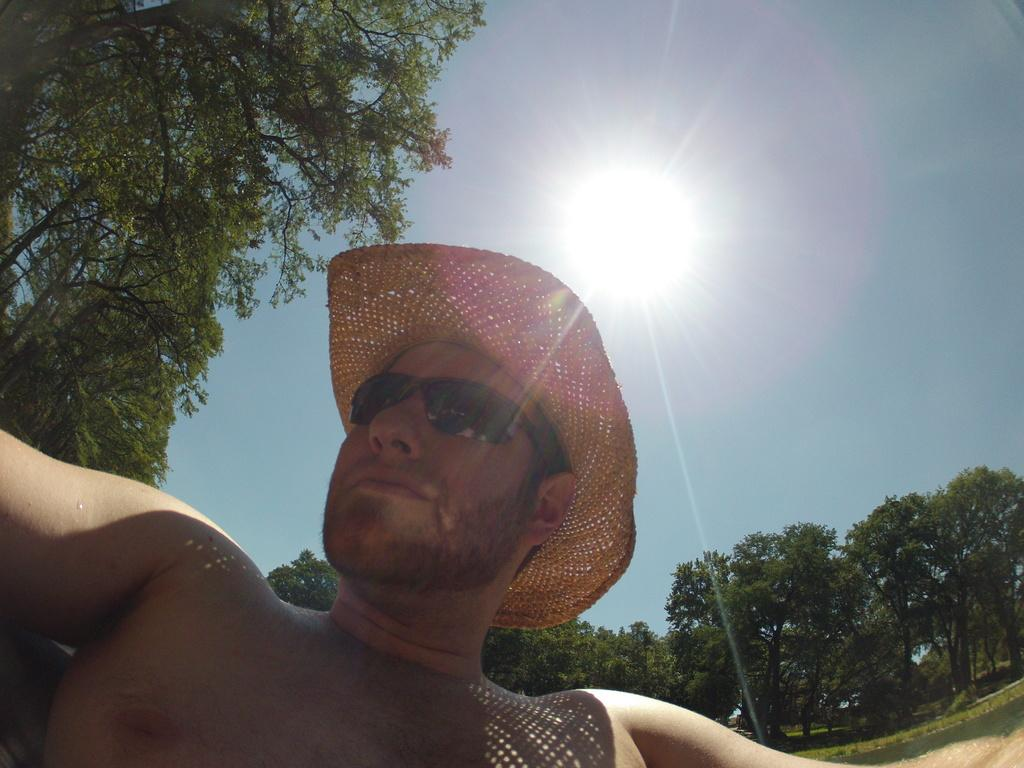What type of natural elements can be seen in the image? There are trees in the image. Can you describe the person in the image? The person is at the bottom of the image and is wearing sunglasses and a hat. What is the weather like in the image? The presence of a sun in the sky suggests that it is a sunny day. What type of bird is flying in the image with a long tail? There is no bird present in the image, and therefore no bird with a long tail can be observed. 